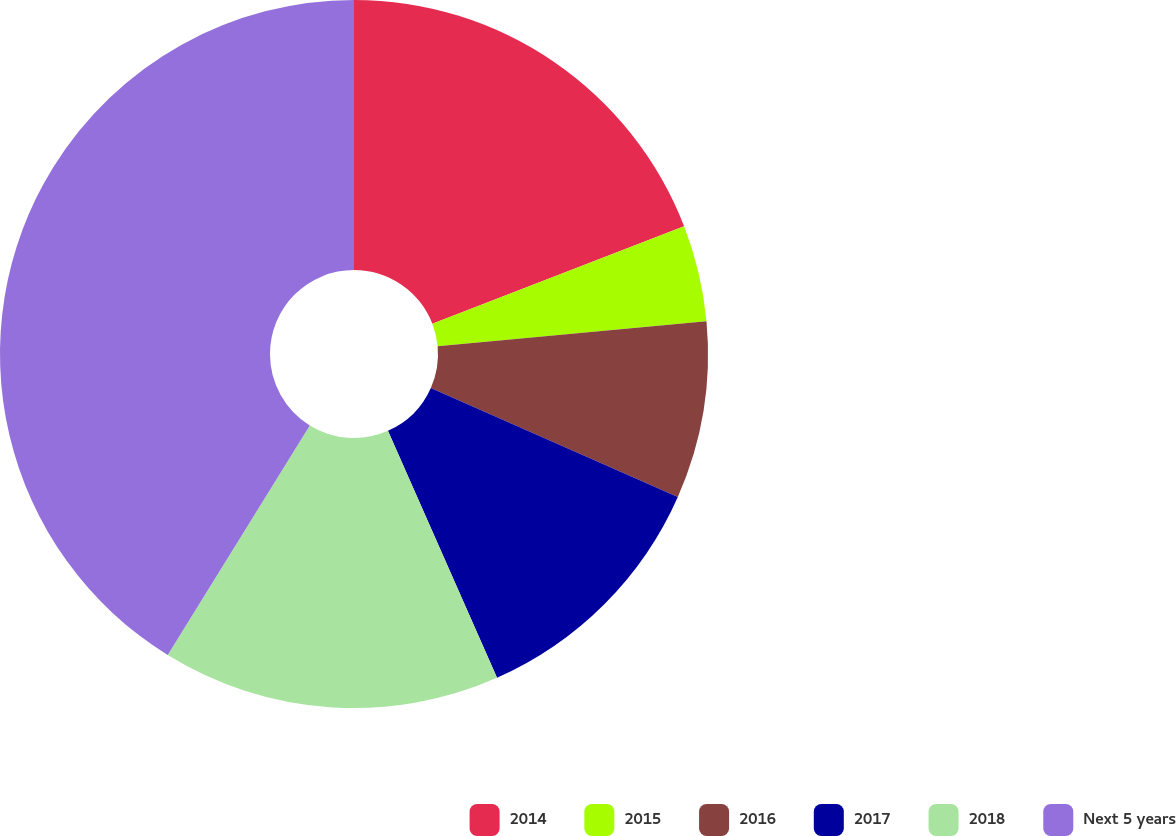<chart> <loc_0><loc_0><loc_500><loc_500><pie_chart><fcel>2014<fcel>2015<fcel>2016<fcel>2017<fcel>2018<fcel>Next 5 years<nl><fcel>19.12%<fcel>4.41%<fcel>8.09%<fcel>11.76%<fcel>15.44%<fcel>41.18%<nl></chart> 